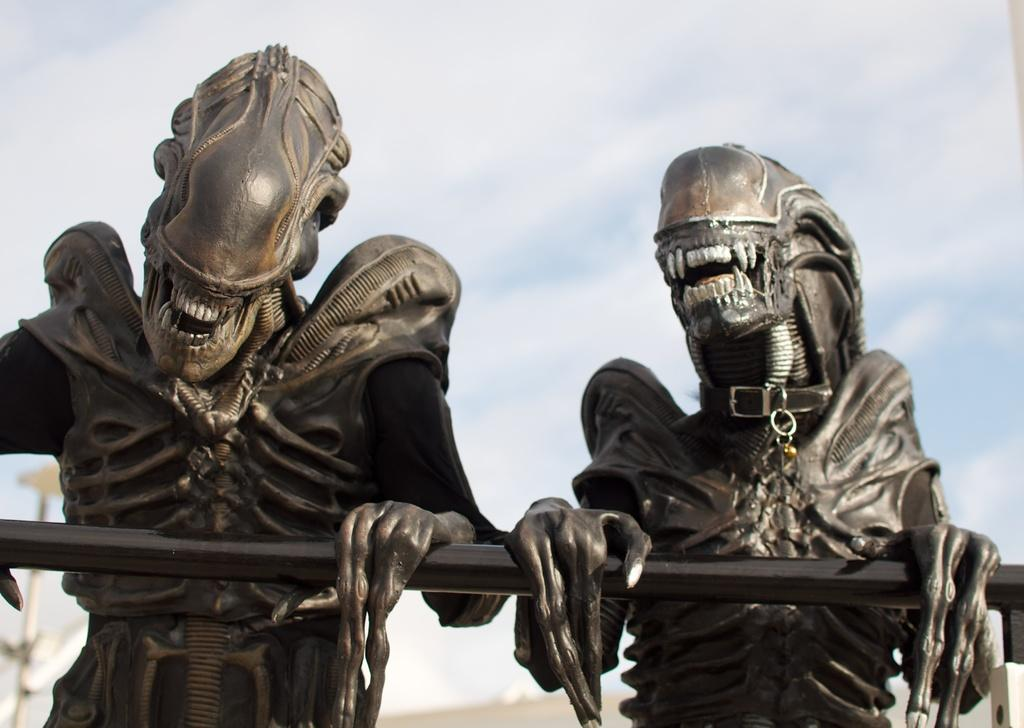What can be seen in the image? There are two statues in the image. What are the statues holding? The statues are holding a black rod. What type of box can be seen in the image? There is no box present in the image; it features two statues holding a black rod. 